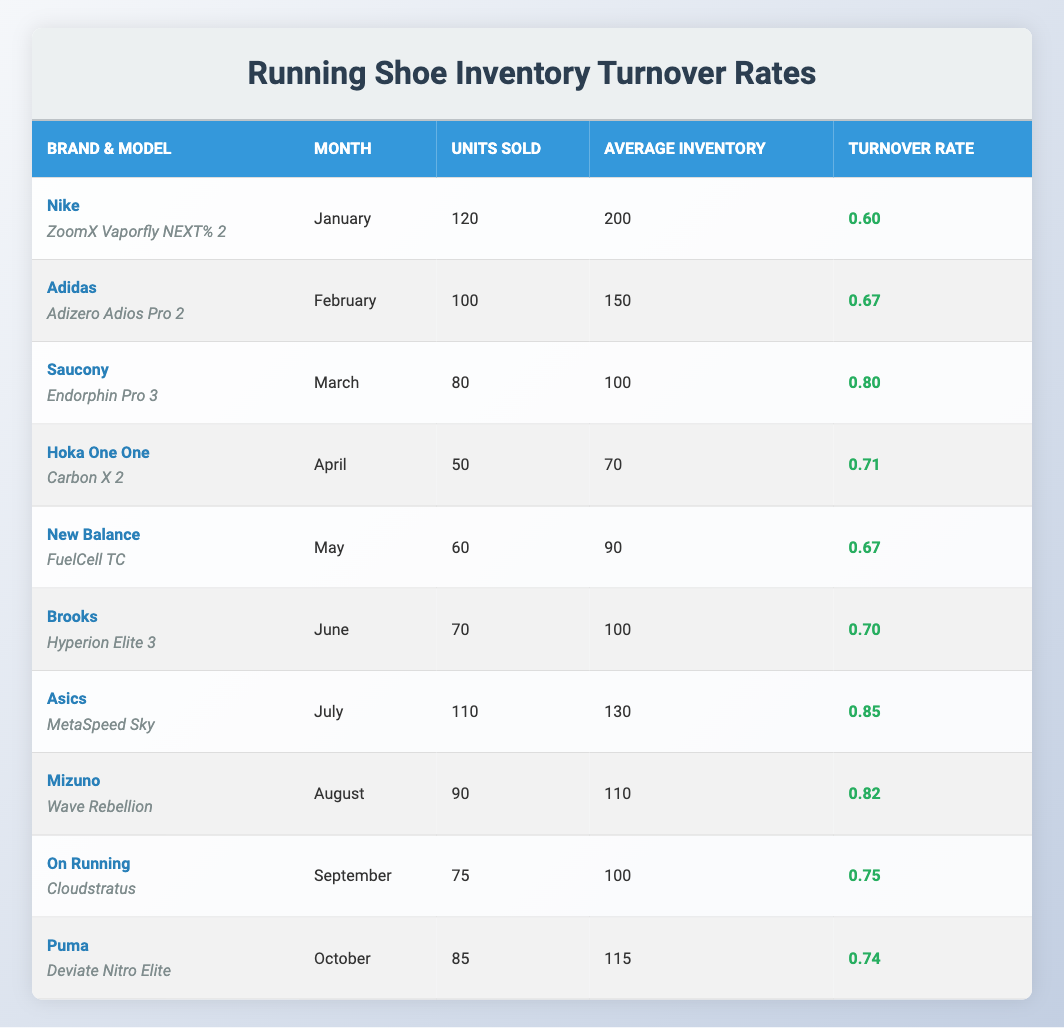What is the turnover rate for the Saucony Endorphin Pro 3 in March? The table indicates that the Saucony Endorphin Pro 3 had a turnover rate listed under the month of March, which is 0.80.
Answer: 0.80 Which brand sold the most units in a single month? Reviewing the table, Nike sold 120 units in January, which is higher than any other brand's sales figures for the remaining months.
Answer: Nike What is the average turnover rate for the brands listed from January to June? To find the average turnover rate from January to June, we sum the turnover rates (0.6 + 0.67 + 0.8 + 0.71 + 0.67 + 0.7) = 3.15. There are 6 months, so the average is 3.15 / 6 = 0.525.
Answer: 0.525 Which shoe models have a turnover rate higher than 0.75? By examining the table, the models with turnover rates higher than 0.75 are the Asics MetaSpeed Sky (0.85), Mizuno Wave Rebellion (0.82), Saucony Endorphin Pro 3 (0.80), and Hoka One One Carbon X 2 (0.71) based on each listed rate.
Answer: Asics MetaSpeed Sky, Mizuno Wave Rebellion, Saucony Endorphin Pro 3 Is the turnover rate for the Puma Deviate Nitro Elite greater than the average turnover rate? The turnover rate for the Puma Deviate Nitro Elite is 0.74, while the average of all turnover rates is 0.722. Since 0.74 is greater than 0.722, the condition is true.
Answer: Yes 